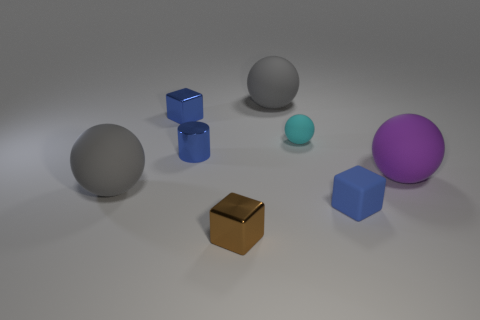Add 1 cyan shiny cylinders. How many objects exist? 9 Subtract all cylinders. How many objects are left? 7 Add 7 tiny blue metal blocks. How many tiny blue metal blocks are left? 8 Add 6 big purple things. How many big purple things exist? 7 Subtract 0 brown spheres. How many objects are left? 8 Subtract all blue shiny cylinders. Subtract all tiny balls. How many objects are left? 6 